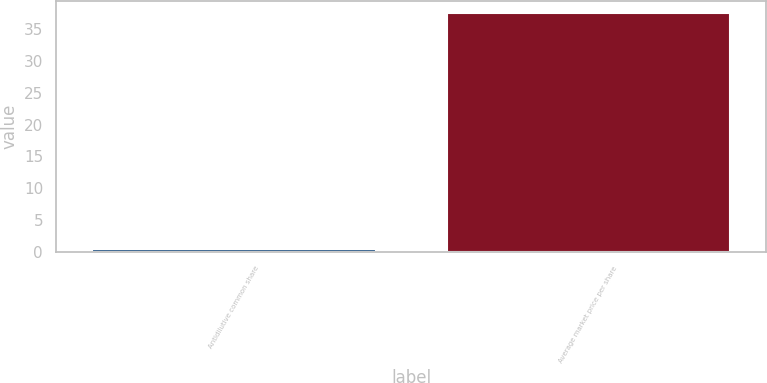<chart> <loc_0><loc_0><loc_500><loc_500><bar_chart><fcel>Antidilutive common share<fcel>Average market price per share<nl><fcel>0.5<fcel>37.53<nl></chart> 